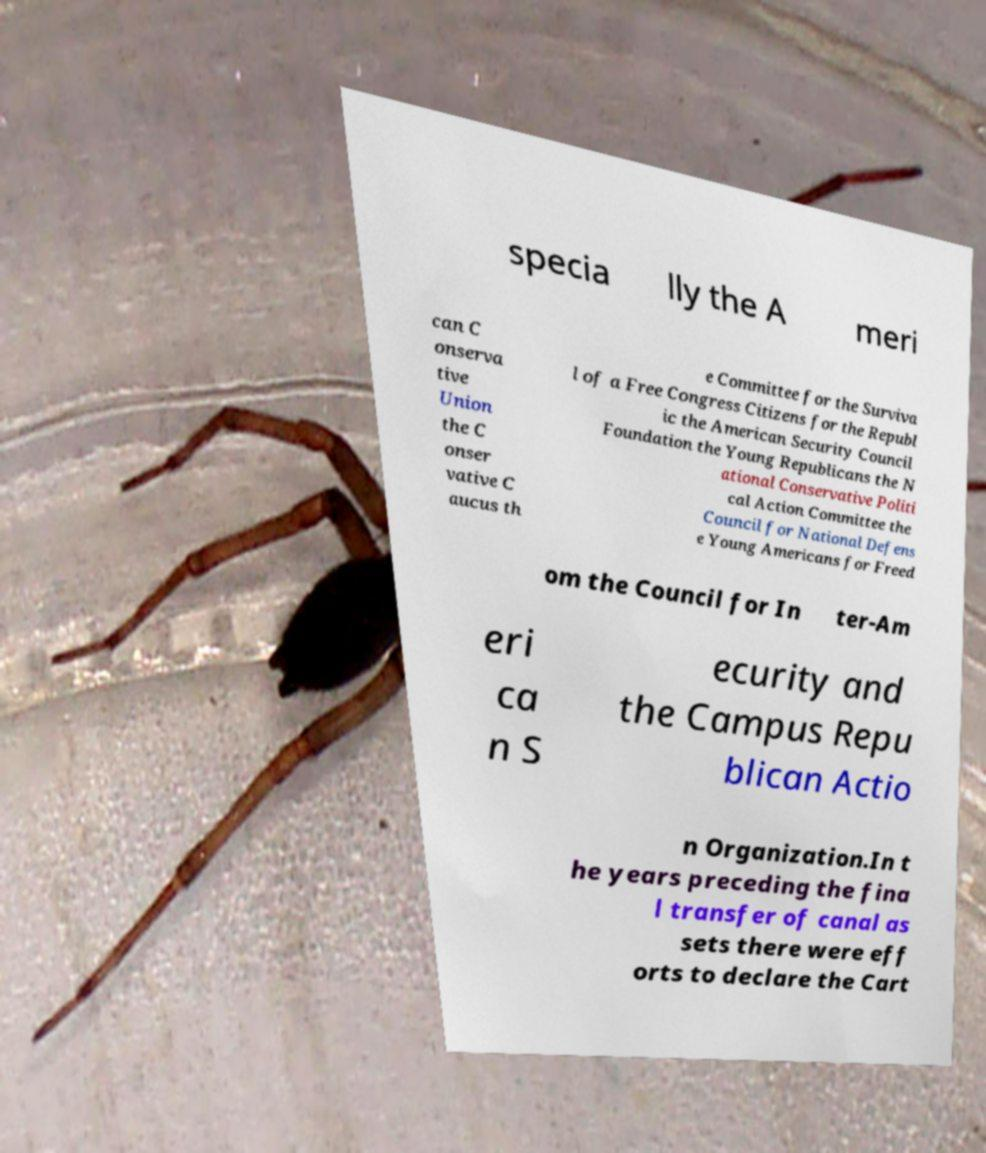I need the written content from this picture converted into text. Can you do that? specia lly the A meri can C onserva tive Union the C onser vative C aucus th e Committee for the Surviva l of a Free Congress Citizens for the Republ ic the American Security Council Foundation the Young Republicans the N ational Conservative Politi cal Action Committee the Council for National Defens e Young Americans for Freed om the Council for In ter-Am eri ca n S ecurity and the Campus Repu blican Actio n Organization.In t he years preceding the fina l transfer of canal as sets there were eff orts to declare the Cart 